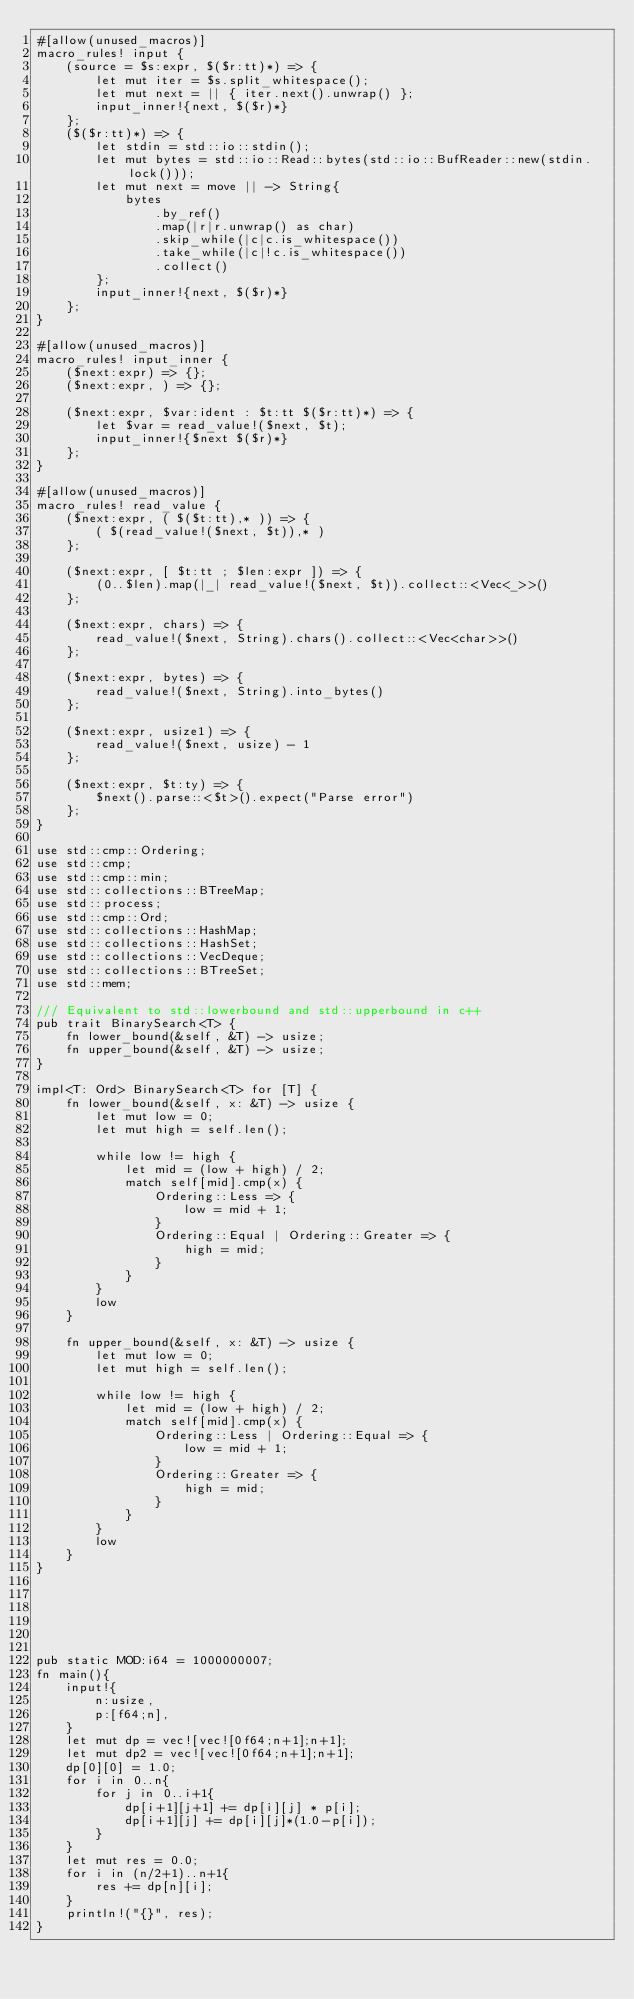<code> <loc_0><loc_0><loc_500><loc_500><_Rust_>#[allow(unused_macros)]
macro_rules! input {
    (source = $s:expr, $($r:tt)*) => {
        let mut iter = $s.split_whitespace();
        let mut next = || { iter.next().unwrap() };
        input_inner!{next, $($r)*}
    };
    ($($r:tt)*) => {
        let stdin = std::io::stdin();
        let mut bytes = std::io::Read::bytes(std::io::BufReader::new(stdin.lock()));
        let mut next = move || -> String{
            bytes
                .by_ref()
                .map(|r|r.unwrap() as char)
                .skip_while(|c|c.is_whitespace())
                .take_while(|c|!c.is_whitespace())
                .collect()
        };
        input_inner!{next, $($r)*}
    };
}
 
#[allow(unused_macros)]
macro_rules! input_inner {
    ($next:expr) => {};
    ($next:expr, ) => {};
 
    ($next:expr, $var:ident : $t:tt $($r:tt)*) => {
        let $var = read_value!($next, $t);
        input_inner!{$next $($r)*}
    };
}
 
#[allow(unused_macros)]
macro_rules! read_value {
    ($next:expr, ( $($t:tt),* )) => {
        ( $(read_value!($next, $t)),* )
    };
 
    ($next:expr, [ $t:tt ; $len:expr ]) => {
        (0..$len).map(|_| read_value!($next, $t)).collect::<Vec<_>>()
    };
 
    ($next:expr, chars) => {
        read_value!($next, String).chars().collect::<Vec<char>>()
    };
 
    ($next:expr, bytes) => {
        read_value!($next, String).into_bytes()
    };
 
    ($next:expr, usize1) => {
        read_value!($next, usize) - 1
    };
 
    ($next:expr, $t:ty) => {
        $next().parse::<$t>().expect("Parse error")
    };
}
 
use std::cmp::Ordering;
use std::cmp;
use std::cmp::min;
use std::collections::BTreeMap;
use std::process;
use std::cmp::Ord;
use std::collections::HashMap;
use std::collections::HashSet;
use std::collections::VecDeque;
use std::collections::BTreeSet;
use std::mem;

/// Equivalent to std::lowerbound and std::upperbound in c++
pub trait BinarySearch<T> {
    fn lower_bound(&self, &T) -> usize;
    fn upper_bound(&self, &T) -> usize;
}
 
impl<T: Ord> BinarySearch<T> for [T] {
    fn lower_bound(&self, x: &T) -> usize {
        let mut low = 0;
        let mut high = self.len();
 
        while low != high {
            let mid = (low + high) / 2;
            match self[mid].cmp(x) {
                Ordering::Less => {
                    low = mid + 1;
                }
                Ordering::Equal | Ordering::Greater => {
                    high = mid;
                }
            }
        }
        low
    }
 
    fn upper_bound(&self, x: &T) -> usize {
        let mut low = 0;
        let mut high = self.len();
 
        while low != high {
            let mid = (low + high) / 2;
            match self[mid].cmp(x) {
                Ordering::Less | Ordering::Equal => {
                    low = mid + 1;
                }
                Ordering::Greater => {
                    high = mid;
                }
            }
        }
        low
    }
}
 
 
 
 
 
 
pub static MOD:i64 = 1000000007;
fn main(){
    input!{
        n:usize,
        p:[f64;n],
    }
    let mut dp = vec![vec![0f64;n+1];n+1];
    let mut dp2 = vec![vec![0f64;n+1];n+1];
    dp[0][0] = 1.0;
    for i in 0..n{
        for j in 0..i+1{
            dp[i+1][j+1] += dp[i][j] * p[i];
            dp[i+1][j] += dp[i][j]*(1.0-p[i]);
        }
    }
    let mut res = 0.0;
    for i in (n/2+1)..n+1{
        res += dp[n][i];
    }
    println!("{}", res);
}

</code> 